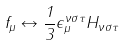Convert formula to latex. <formula><loc_0><loc_0><loc_500><loc_500>f _ { \mu } \leftrightarrow \frac { 1 } { 3 } \epsilon _ { \mu } ^ { \nu \sigma \tau } H _ { \nu \sigma \tau }</formula> 